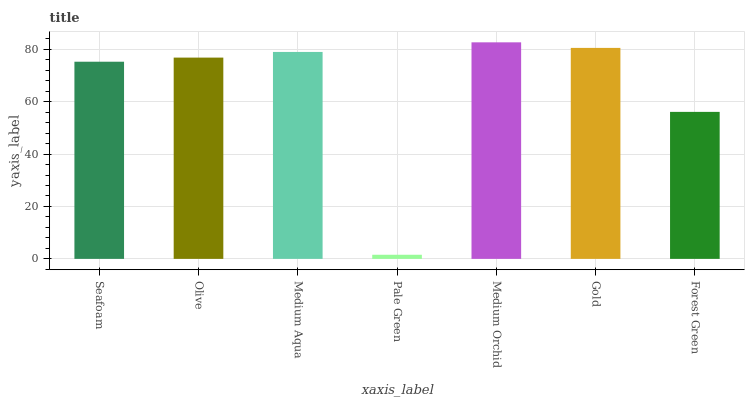Is Pale Green the minimum?
Answer yes or no. Yes. Is Medium Orchid the maximum?
Answer yes or no. Yes. Is Olive the minimum?
Answer yes or no. No. Is Olive the maximum?
Answer yes or no. No. Is Olive greater than Seafoam?
Answer yes or no. Yes. Is Seafoam less than Olive?
Answer yes or no. Yes. Is Seafoam greater than Olive?
Answer yes or no. No. Is Olive less than Seafoam?
Answer yes or no. No. Is Olive the high median?
Answer yes or no. Yes. Is Olive the low median?
Answer yes or no. Yes. Is Pale Green the high median?
Answer yes or no. No. Is Gold the low median?
Answer yes or no. No. 